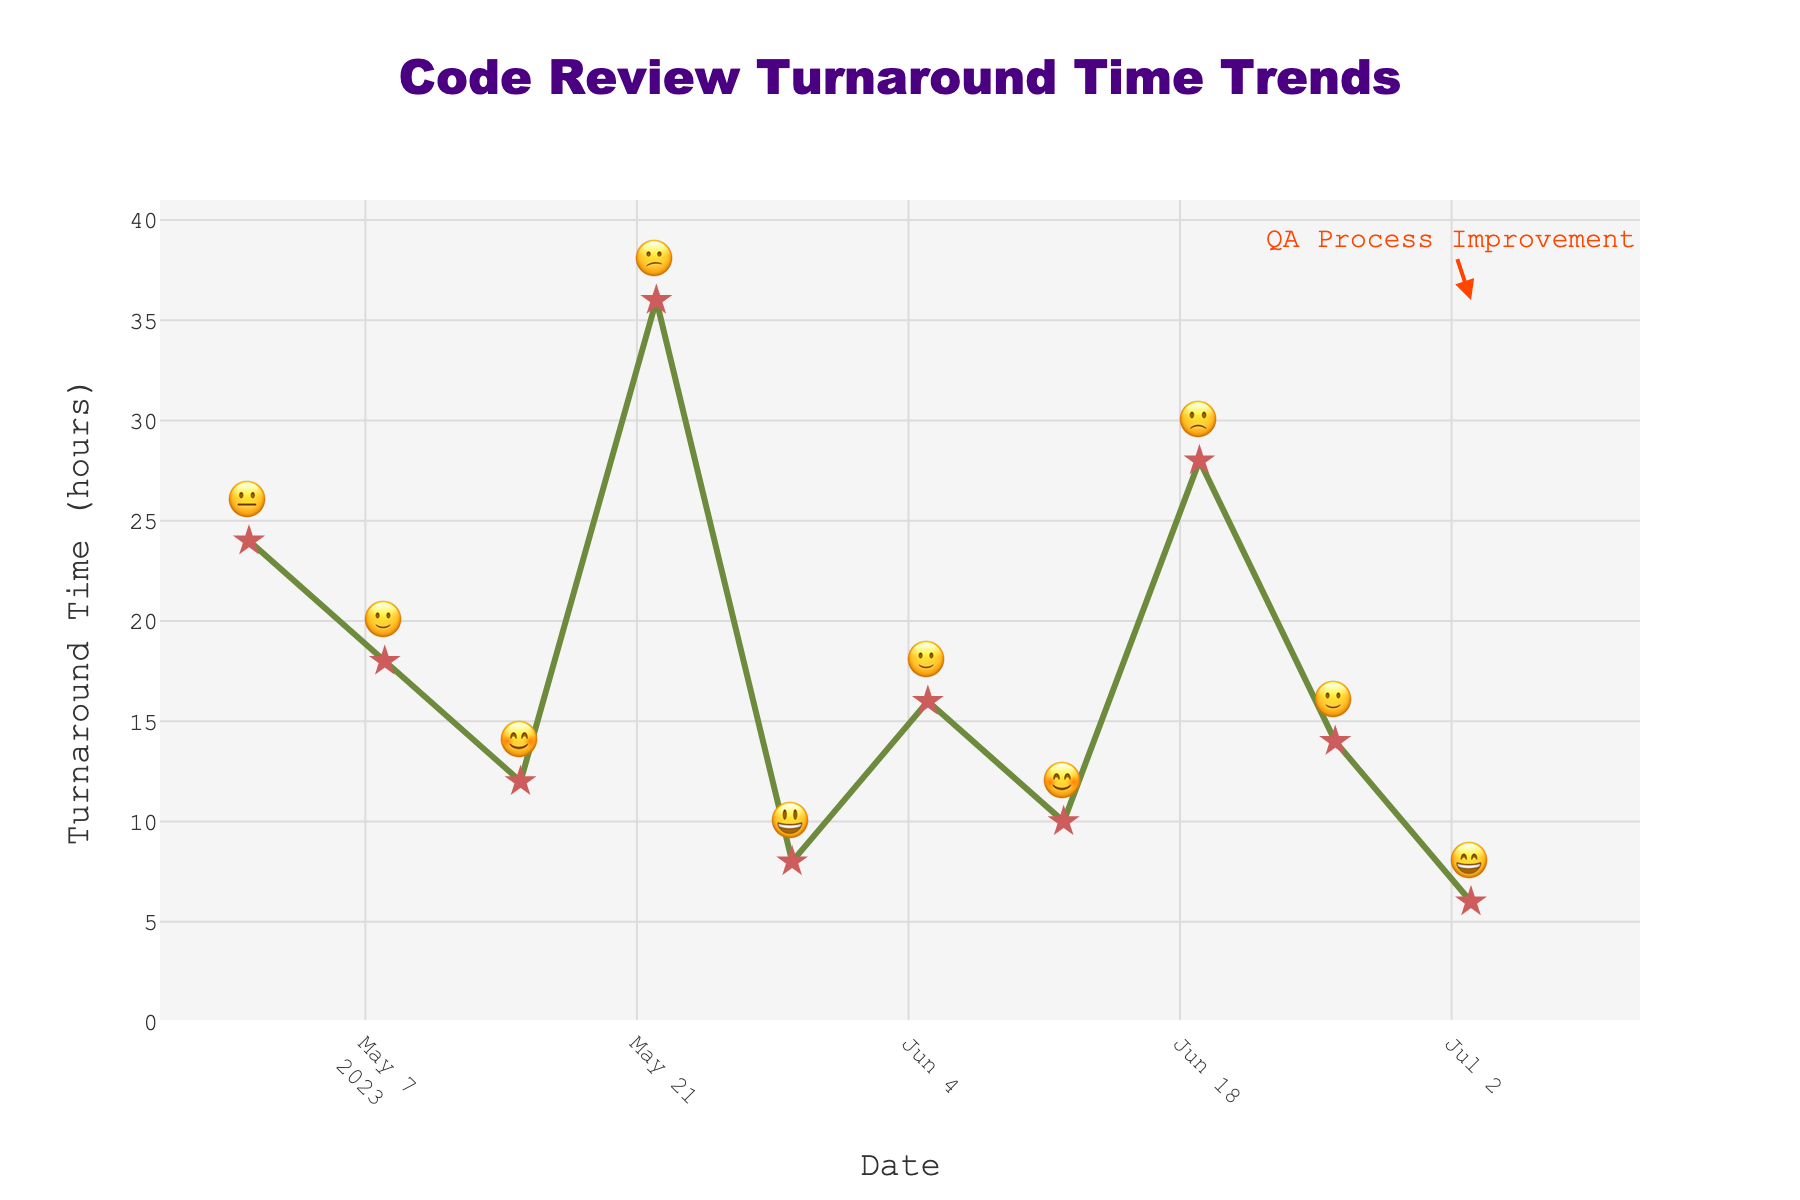What is the title of the chart? The title is typically found at the top-center of the chart, indicating the main subject of the visual representation. Here, it is "Code Review Turnaround Time Trends".
Answer: Code Review Turnaround Time Trends How many data points have a mood indicator of "😊"? By checking each point's mood emoji, we can count the occurrences of "😊". There are two such points: 2023-05-15 and 2023-06-12.
Answer: 2 What was the turnaround time on 2023-05-29, and what was the mood? Find the date 2023-05-29 on the x-axis, check its corresponding y-axis value and the mood indicator text above the point. The turnaround time was 8 hours, and the mood was "😃".
Answer: 8 hours, 😃 Which date had the highest turnaround time, and what was the mood on that day? Identify the highest point on the y-axis to see which date it maps to, then look at the mood emoji above that point. The date is 2023-05-22, and the mood is "😕".
Answer: 2023-05-22, 😕 What is the average turnaround time for all the dates provided? First sum up all the turnaround times: 24 + 18 + 12 + 36 + 8 + 16 + 10 + 28 + 14 + 6 = 172. Then, divide this sum by the number of data points (10). The average turnaround time is 172 / 10 = 17.2 hours.
Answer: 17.2 hours Between which two consecutive dates did the turnaround time drop the most? Calculate the differences in turnaround times between each pair of consecutive dates and identify the largest drop. The largest drop is between 2023-05-22 (36 hours) and 2023-05-29 (8 hours), with a decrease of 28 hours.
Answer: 2023-05-22 and 2023-05-29 Across all data points, how many times was the mood "🙂"? Count the number of occurrences of the "🙂" mood emoji. The dates are 2023-05-08, 2023-06-05, and 2023-06-26, so it appears three times.
Answer: 3 What trend can you observe regarding turnaround times and mood indicators through May and June? By examining the plot, notice how the turnaround times fluctuate and how the mood emojis vary in expression. Longer turnaround times generally correspond with less happy emojis, while shorter times are paired with happier emojis. In June, improvement is seen until 2023-06-19, which has a higher turnaround time and a less happy emoji.
Answer: Shorter times = happier, Longer times = less happy What was the overall trend in turnaround time from the start date to the end date? Trace the line from the first to the last point on the chart to understand the general direction. The line becomes jagged, but there is an overall downward trend from 24 hours on 2023-05-01 to 6 hours on 2023-07-03.
Answer: Overall decreasing What annotation is highlighted in the chart, and why is it significant? The annotation is "QA Process Improvement," pointing to the highest turnaround time on 2023-05-22. This signifies a key moment of change or focus area for improvement in the QA process.
Answer: QA Process Improvement, 2023-05-22 